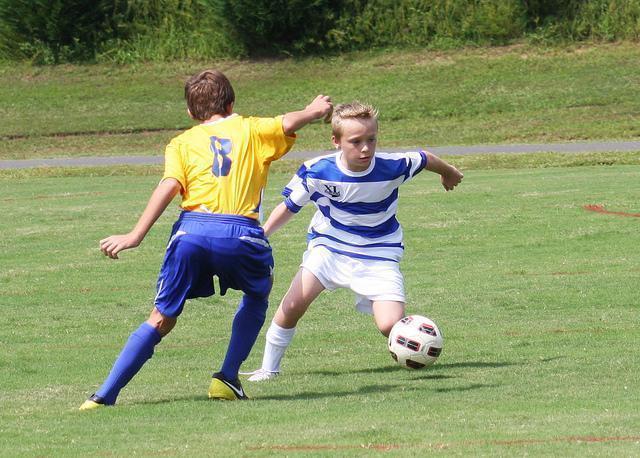What is the boy in blue and white trying to do?
Make your selection and explain in format: 'Answer: answer
Rationale: rationale.'
Options: Backflip, kick ball, tackle boy, grab ball. Answer: kick ball.
Rationale: The boys are kicking the ball. 